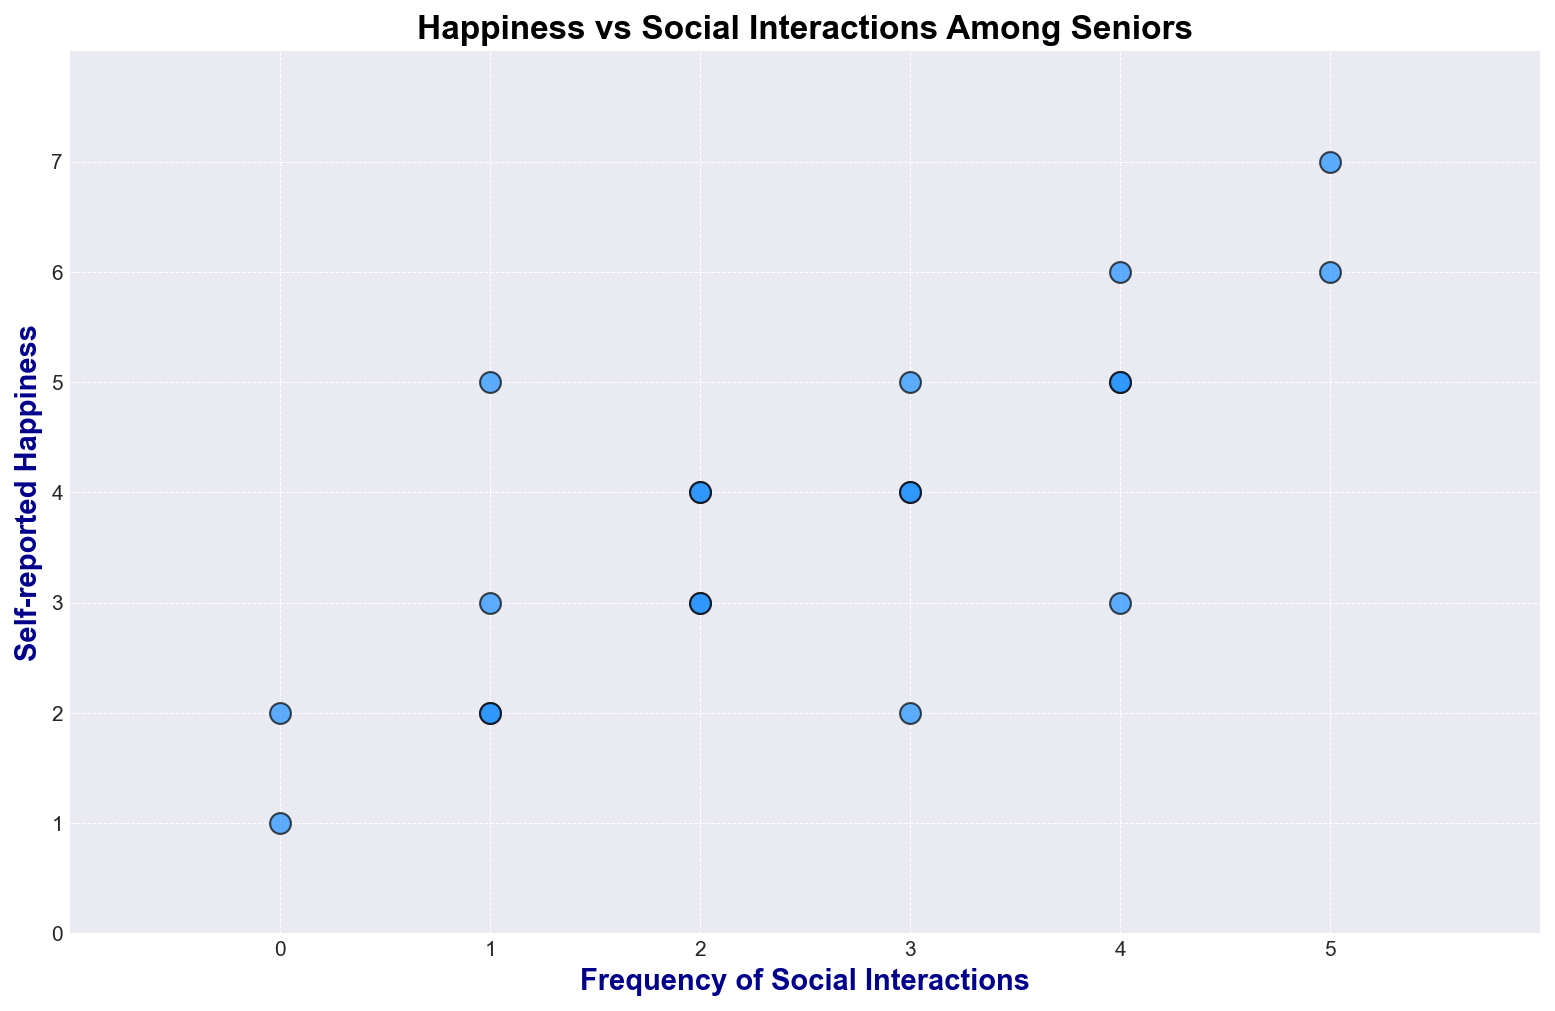What is the range of the Frequency of Social Interactions shown in the plot? To determine the range, observe the lowest and highest values on the x-axis labeled "Frequency of Social Interactions". The lowest value is 0, and the highest value is 5.
Answer: 0 to 5 How many points have a Frequency of Social Interactions equal to 3? Count the number of data points aligned with the x-axis value of 3. There are 3 points plotted at x=3.
Answer: 3 points At what frequency of social interactions do you see the highest self-reported happiness? Check for the data point with the highest y-value and note its corresponding x-axis value. The highest self-reported happiness (y=7) corresponds to a frequency of social interactions (x=5).
Answer: 5 Is there a positive overall trend between Frequency of Social Interactions and Self-reported Happiness among seniors? Generally, the points seem to ascend from the bottom-left to the top-right. This indicates that as the frequency of social interactions increases, self-reported happiness also tends to increase.
Answer: Yes What is the self-reported happiness when the frequency of social interactions is 2? Identify data points where the x-coordinate is 2 and note the corresponding y-coordinates. The points are at (2, 4), (2, 3), and (2, 4).
Answer: 4, 3, 4 What is the average self-reported happiness for a senior with 4 social interactions per week? Locate the points where x = 4, which have y-values of 6, 5, 5, and 3. The average (6+5+5+3)/4 = 4.75.
Answer: 4.75 Compare the range of self-reported happiness for 1 social interaction and 5 social interactions. Which one is wider? For 1 interaction, y-values are 3, 2, and 5. The range is 5-2 = 3. For 5 interactions, y-values are 6 and 7. The range is 7-6 = 1. 1 interaction has a wider range.
Answer: 1 interaction wider Which exact data point corresponds to the lowest self-reported happiness on the plot? Identify the point with the smallest y-value. The lowest self-reported happiness (y=1) corresponds to (0, 1).
Answer: (0, 1) When the frequency of social interactions is 0, how does self-reported happiness compare to the average happiness for all other frequencies? For 0 interactions, self-reported happiness values are 2 and 1. Average is (2+1)/2 = 1.5. For other frequencies, average can be calculated by summing y-values and dividing by the count, showing a generally higher average.
Answer: Lower 